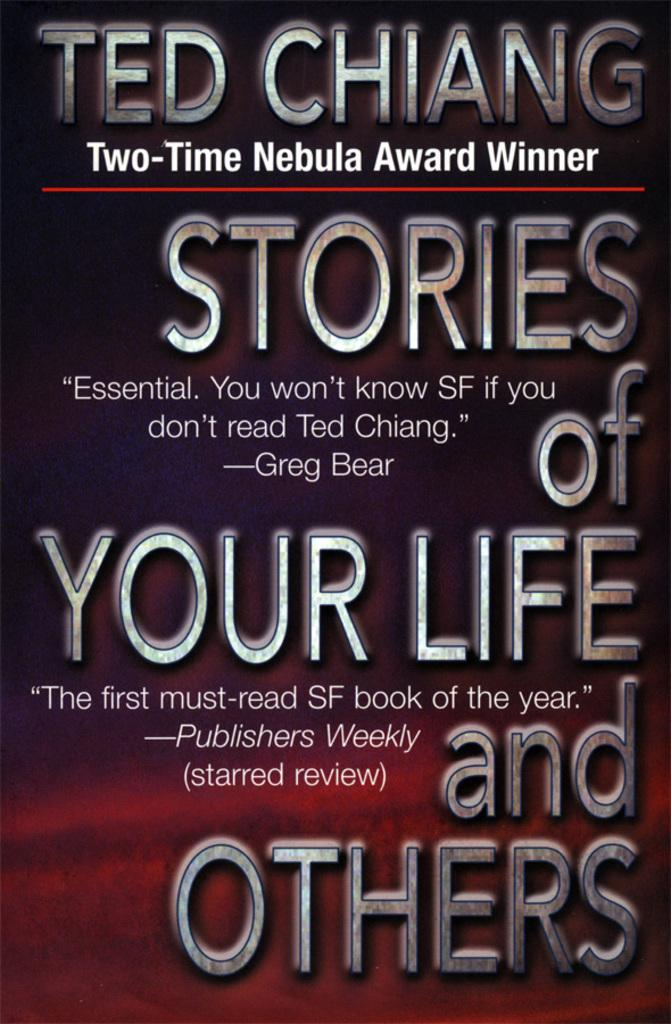Provide a one-sentence caption for the provided image. A book cover displays the name Ted Chiang, who is the author. 